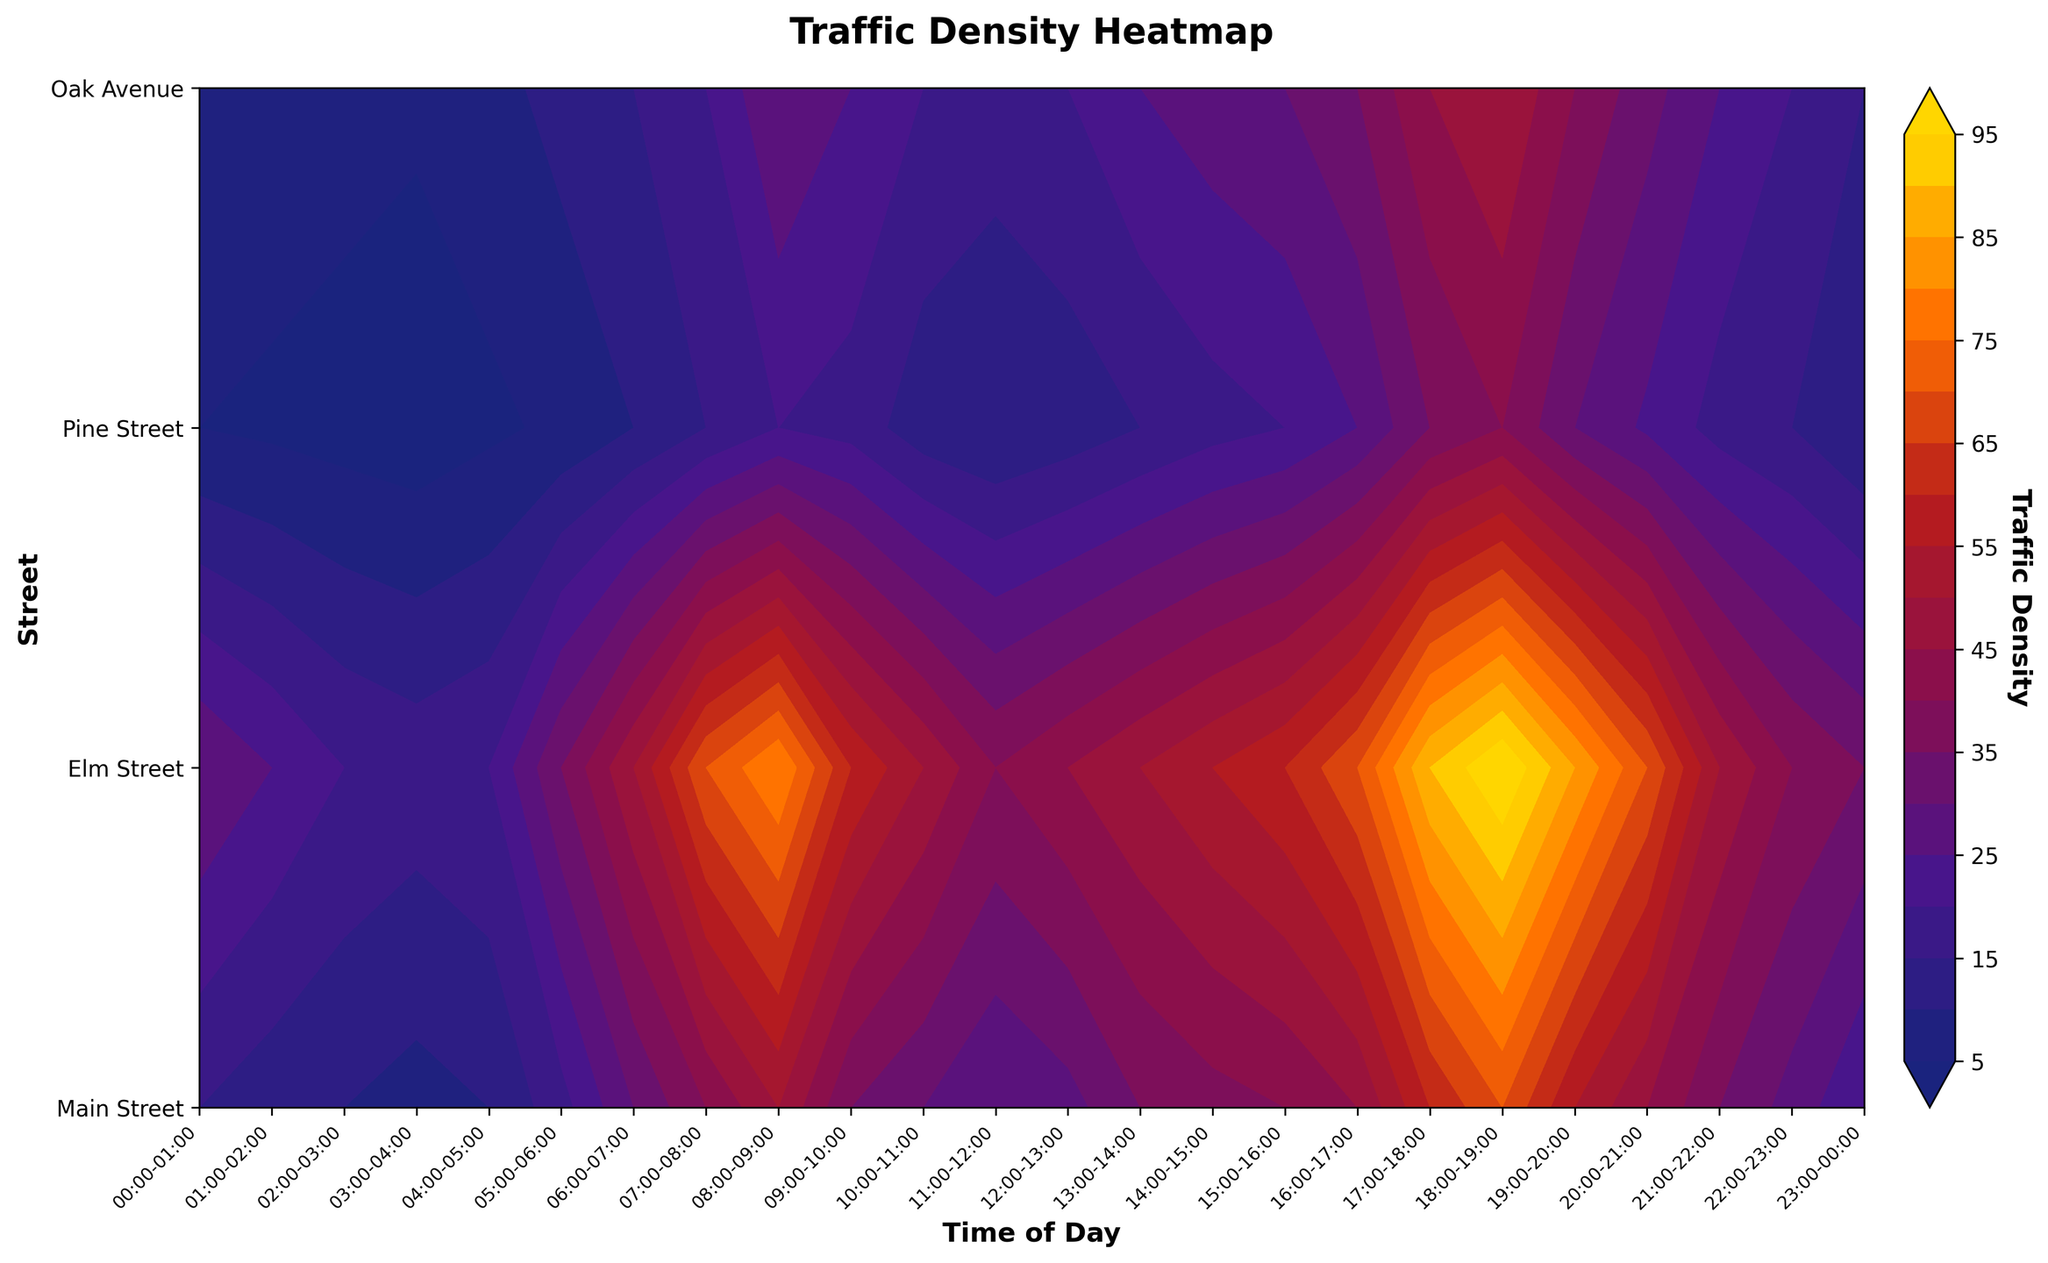What time of day does Main Street experience the highest traffic density? To determine when Main Street has the highest traffic density, look at the contour plot where Main Street's density is the highest. Refer to the x-axis for time, and the color gradient for the highest density.
Answer: 18:00-19:00 Which streets are underutilized based on the annotations? The contour plot includes annotations pointing to the underutilized streets. Look for the arrows labeled "Underutilized" to identify these streets.
Answer: Pine Street, Oak Avenue At what times of the day are the peak traffic density annotations marked? Peak times are annotated on the plot with arrows and labels. To find these times, look at where the annotations are pointing on the x-axis.
Answer: 08:00-09:00, 17:00-18:00, 18:00-19:00 How does the traffic density at 09:00-10:00 compare between Elm Street and Pine Street? Examine the contour levels at 09:00-10:00 for Elm Street and Pine Street. Compare the colors or contour levels at these intersections.
Answer: Elm Street has higher traffic density than Pine Street What is the overall trend of traffic density on Main Street throughout the day? To identify the trend, observe the contour changes along Main Street from the start of the day to the end. Look for increasing or decreasing patterns in the color gradient.
Answer: The traffic density increases in the morning, peaks around 18:00-19:00, and then decreases 